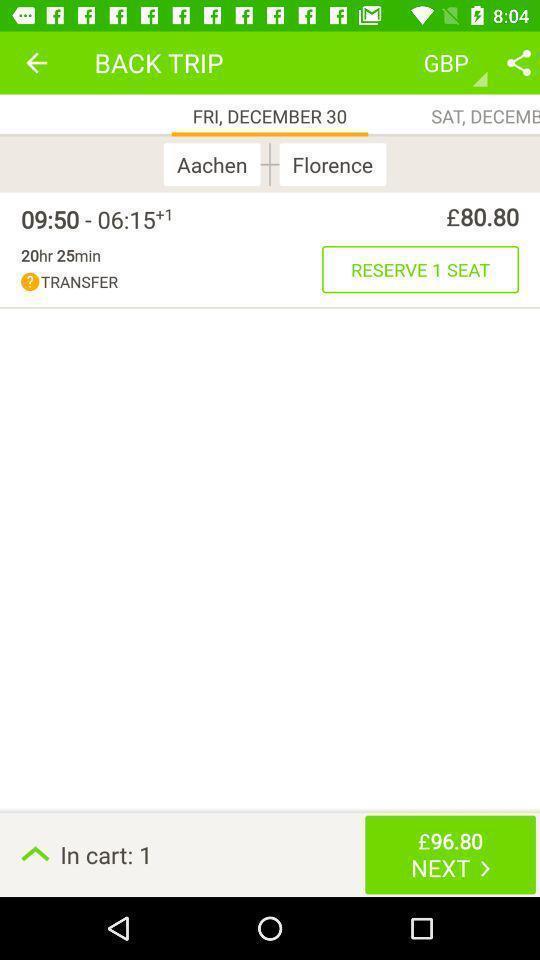Tell me about the visual elements in this screen capture. Screen page displaying details of trip. 